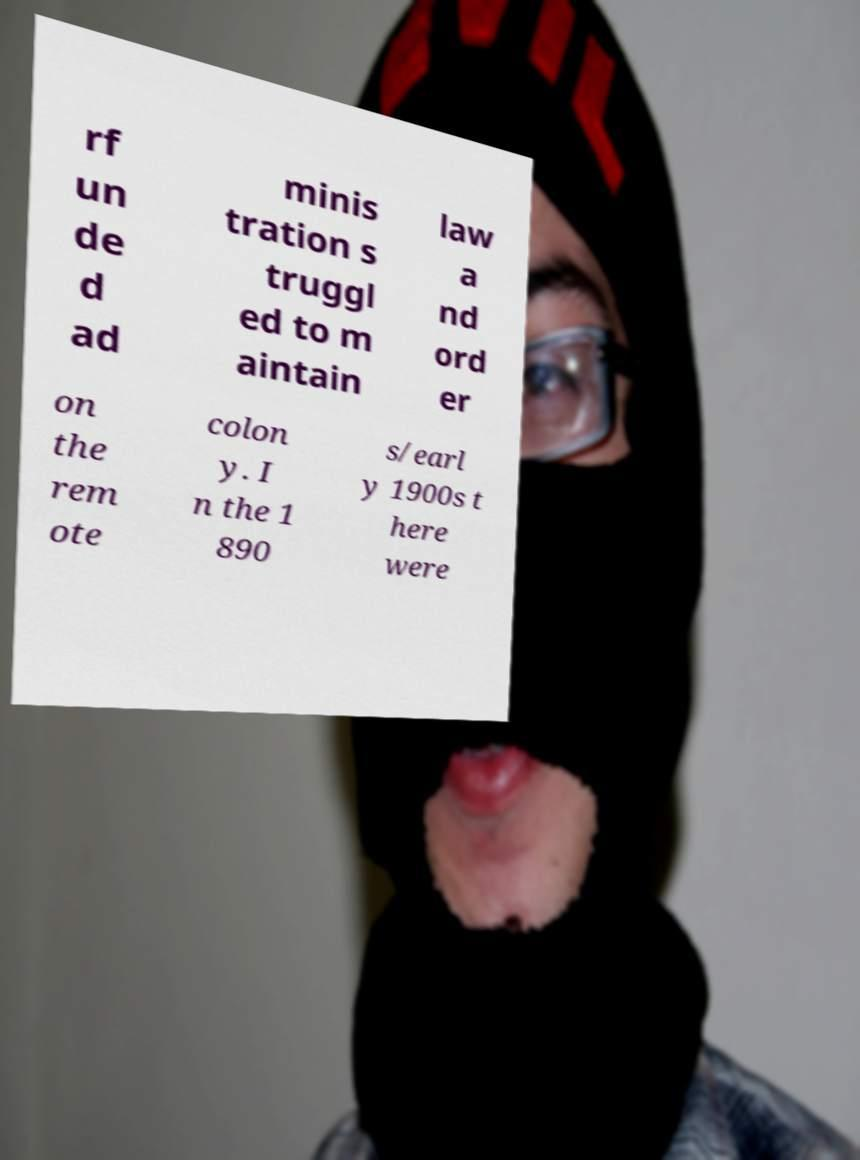Could you assist in decoding the text presented in this image and type it out clearly? rf un de d ad minis tration s truggl ed to m aintain law a nd ord er on the rem ote colon y. I n the 1 890 s/earl y 1900s t here were 